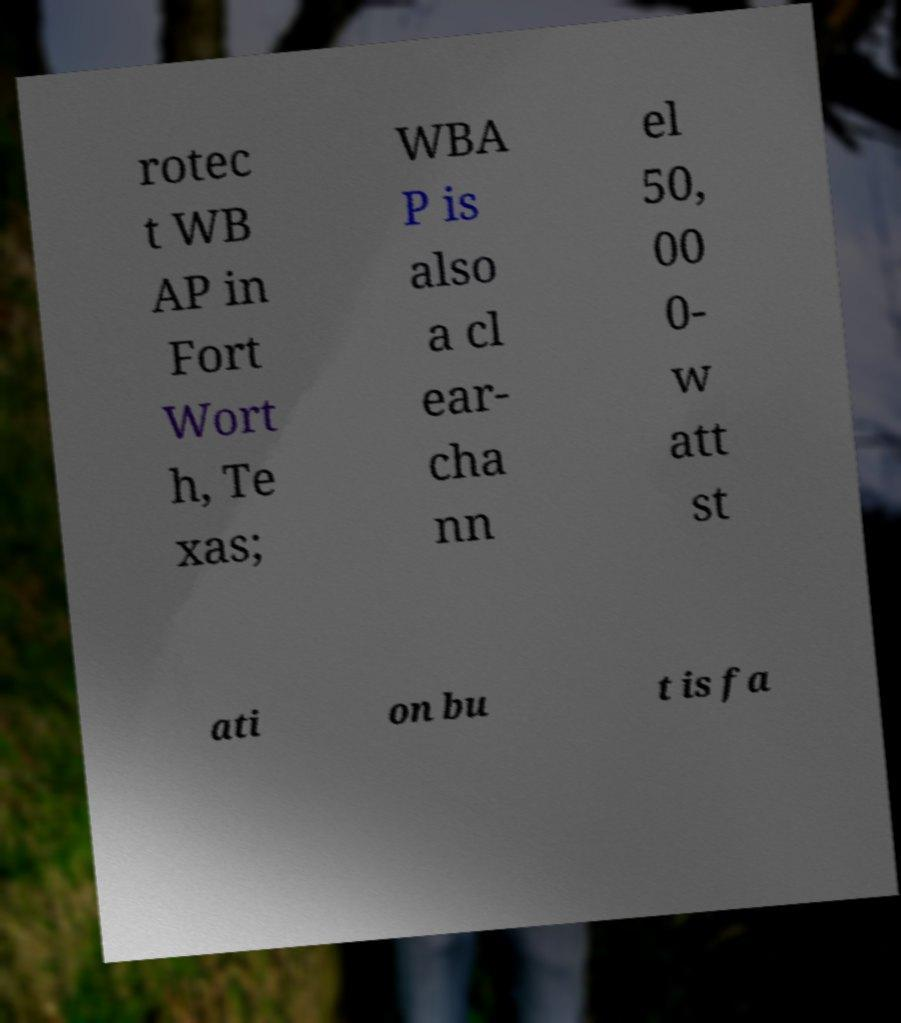For documentation purposes, I need the text within this image transcribed. Could you provide that? rotec t WB AP in Fort Wort h, Te xas; WBA P is also a cl ear- cha nn el 50, 00 0- w att st ati on bu t is fa 